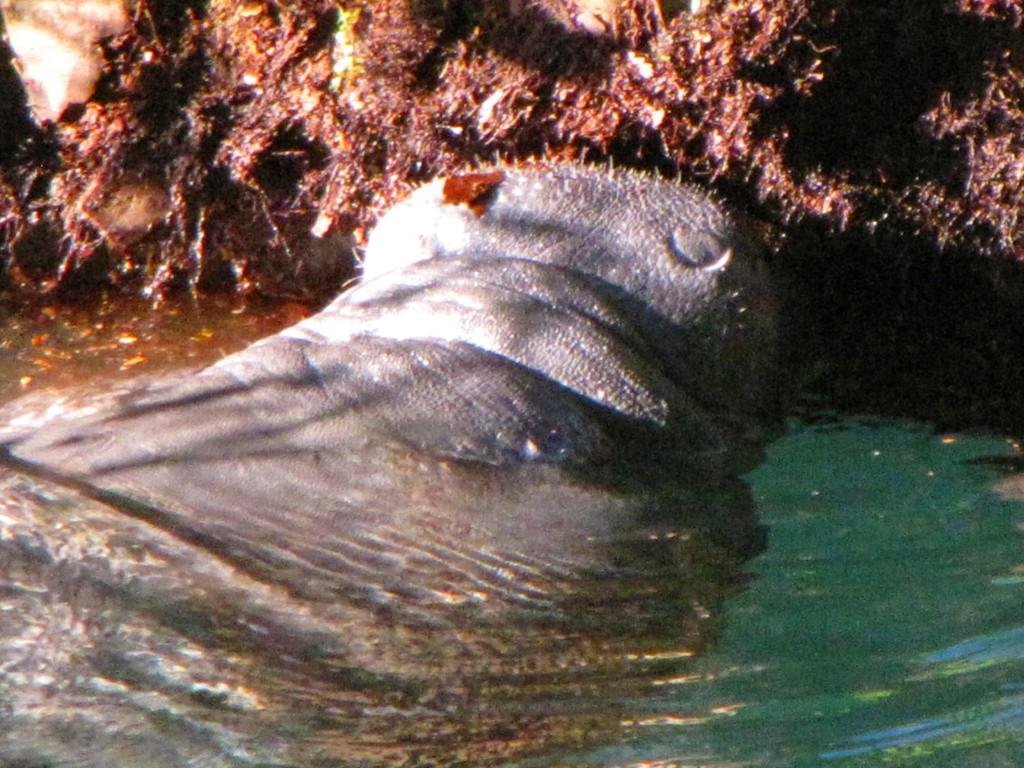What type of animal can be seen in the image? There is an animal in the image, but its specific type cannot be determined from the provided facts. What is the ground made of in the image? Soil is present in the image. What else is visible in the image besides the animal and soil? Water is visible in the image. What type of art can be seen in the image? There is no art present in the image; it features an animal, soil, and water. How does the animal provide comfort to the viewer in the image? The animal does not provide comfort to the viewer in the image, as there is no indication of its behavior or interaction with the viewer. 